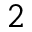Convert formula to latex. <formula><loc_0><loc_0><loc_500><loc_500>2</formula> 